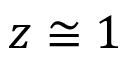Convert formula to latex. <formula><loc_0><loc_0><loc_500><loc_500>z \cong 1</formula> 